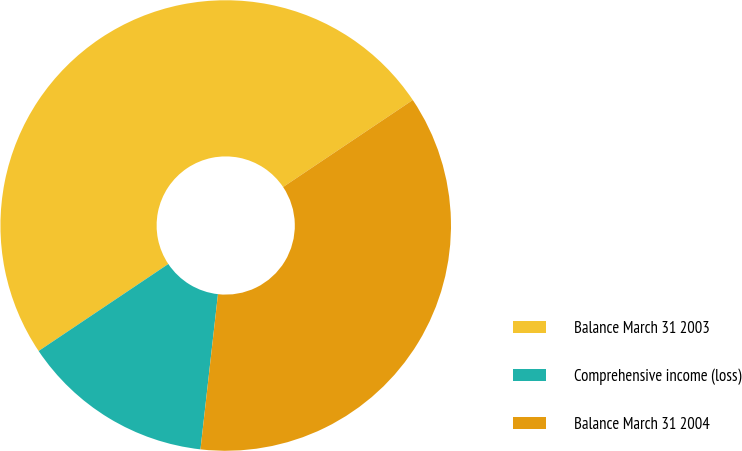Convert chart to OTSL. <chart><loc_0><loc_0><loc_500><loc_500><pie_chart><fcel>Balance March 31 2003<fcel>Comprehensive income (loss)<fcel>Balance March 31 2004<nl><fcel>50.0%<fcel>13.81%<fcel>36.19%<nl></chart> 